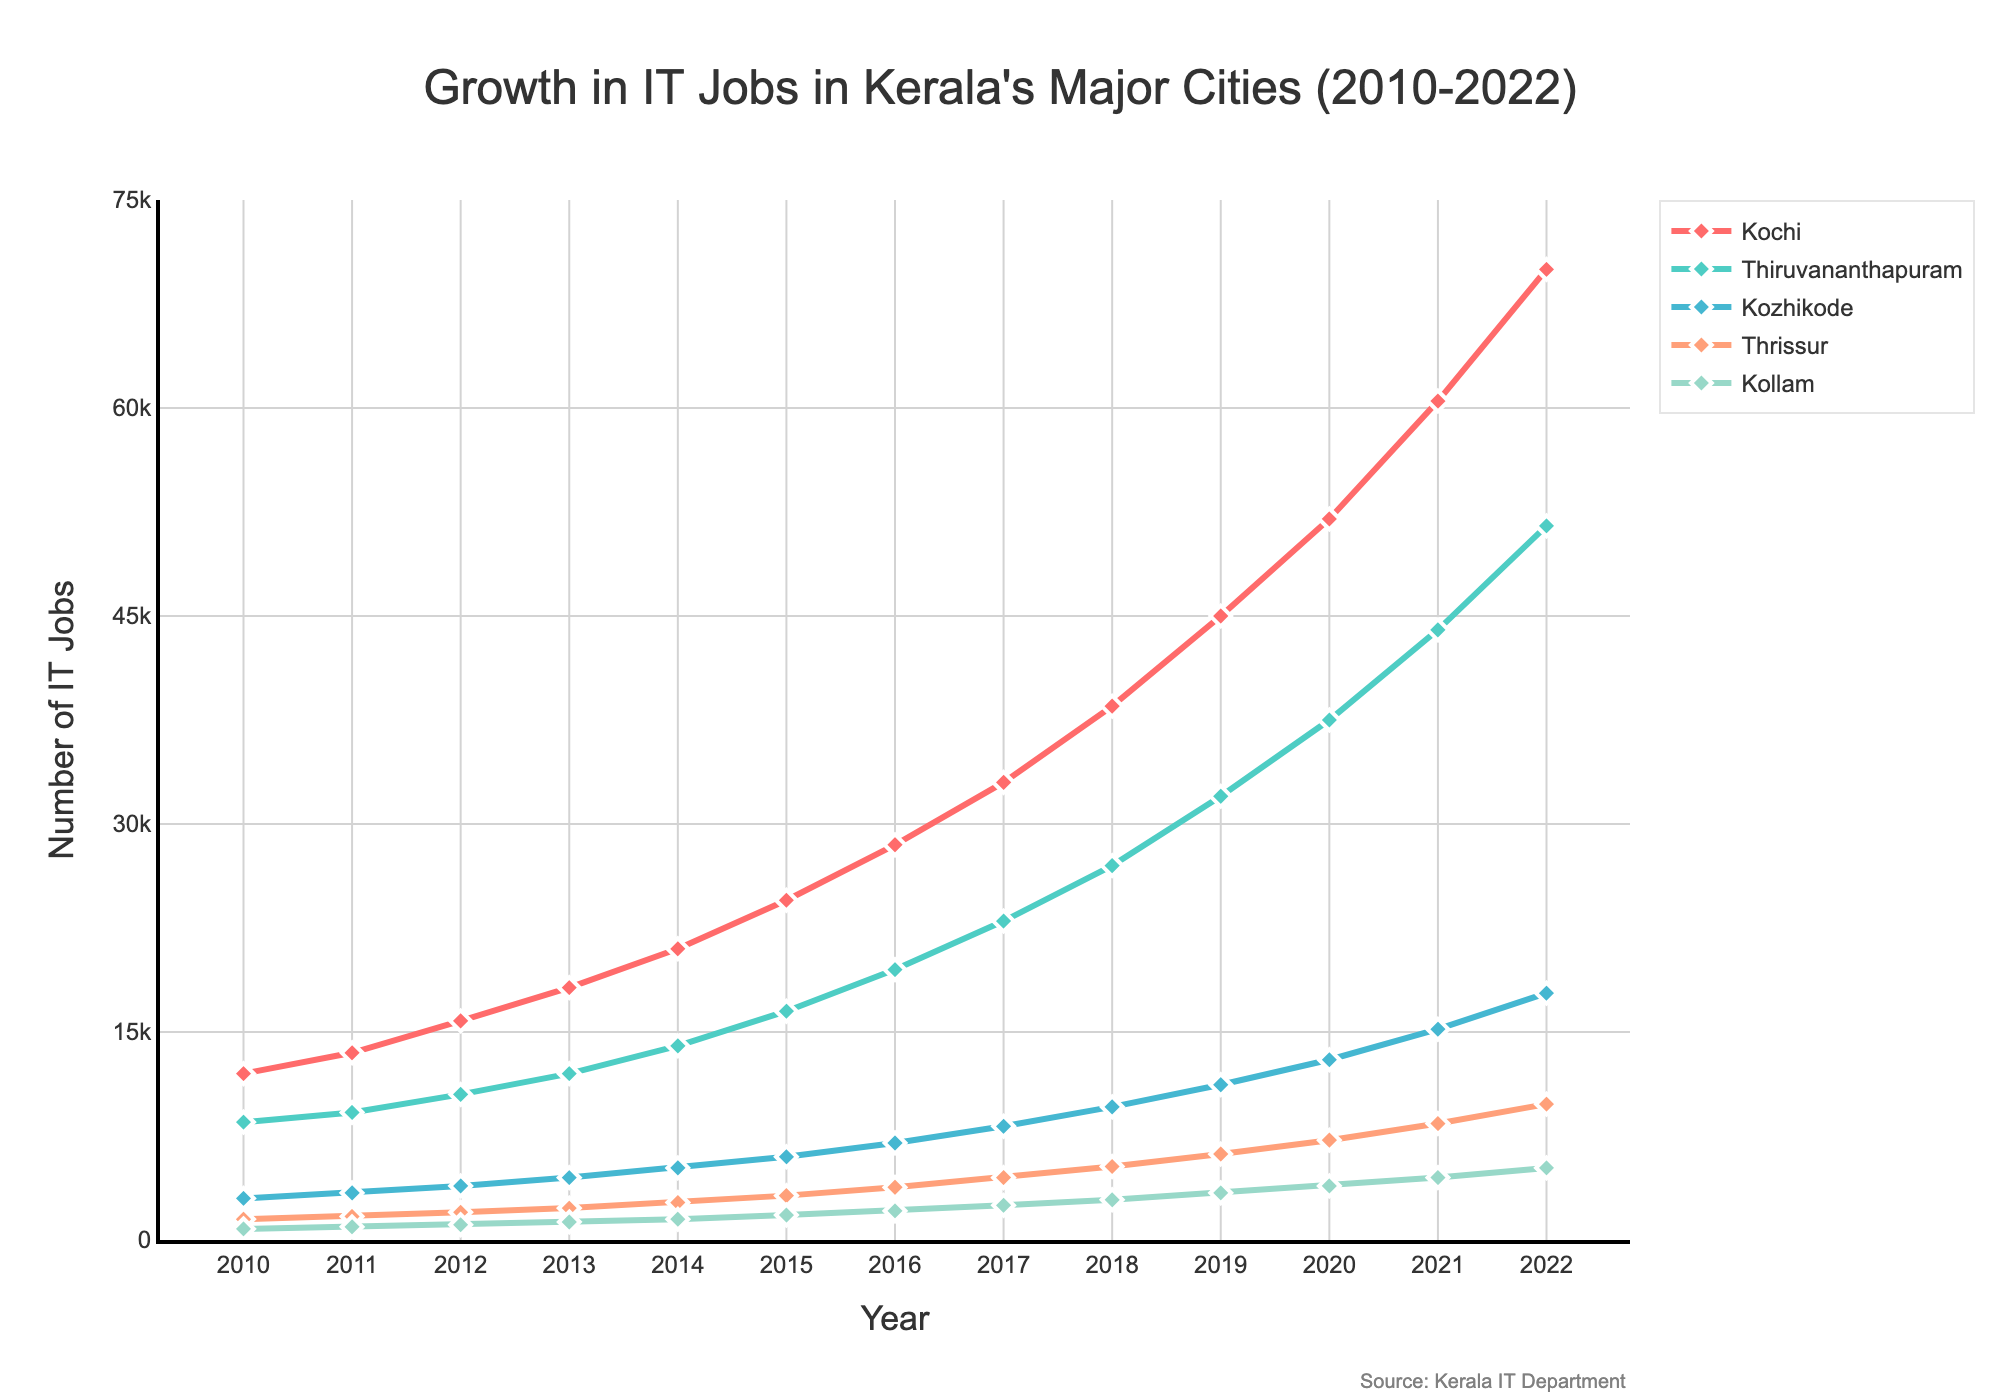What was the total number of IT jobs across all five cities in 2020? To find the total number of IT jobs across all five cities in 2020, sum the number of IT jobs for each city in that year. Kochi had 52000, Thiruvananthapuram had 37500, Kozhikode had 13000, Thrissur had 7200, and Kollam had 3900. Total = 52000 + 37500 + 13000 + 7200 + 3900 = 113600.
Answer: 113600 Which city experienced the highest growth in IT jobs from 2010 to 2022? Calculate the change in IT job numbers from 2010 to 2022 for each city and compare. Kochi: 70000 - 12000 = 58000, Thiruvananthapuram: 51500 - 8500 = 43000, Kozhikode: 17800 - 3000 = 14800, Thrissur: 9800 - 1500 = 8300, Kollam: 5200 - 800 = 4400. Kochi experienced the highest growth with an increase of 58000 jobs.
Answer: Kochi Which two cities had the closest number of IT jobs in 2015? Compare the number of IT jobs in 2015 for all cities. Kochi: 24500, Thiruvananthapuram: 16500, Kozhikode: 6000, Thrissur: 3200, Kollam: 1800. The closest numbers are 3200 (Thrissur) and 1800 (Kollam), with a difference of 1400 jobs.
Answer: Thrissur and Kollam By how much did the number of IT jobs in Kozhikode increase from 2015 to 2020? Subtract the number of IT jobs in 2015 from the number in 2020 for Kozhikode. 2020: 13000, 2015: 6000. Increase = 13000 - 6000 = 7000.
Answer: 7000 What is the average annual growth rate of IT jobs in Thiruvananthapuram from 2010 to 2022? First, find the initial and final number of jobs in Thiruvananthapuram in the given period: initial (2010) = 8500, final (2022) = 51500. Annual growth rate = (final - initial) / number of years = (51500 - 8500) / (2022 - 2010) = 43000 / 12 = 3583.33 jobs per year.
Answer: 3583.33 Which year saw the largest increase in IT jobs for Kochi, and how many jobs were added that year? Calculate the annual increase for each year by subtracting the previous year's number from the current year's number. 2018 to 2019 saw the largest increase: 2019 (45000) - 2018 (38500) = 6500 jobs.
Answer: 2019, 6500 In which city did the number of IT jobs double from 2010 to 2016? Find out whether the number of IT jobs in 2016 is at least double the number of IT jobs in 2010 for each city. Kochi: 28500 (2016) vs. 12000 (2010) — yes, doubled. Thiruvananthapuram: 19500 vs. 8500 — yes. Kozhikode: 7000 vs. 3000 — yes. Thrissur: 3800 vs. 1500 — yes. Kollam: 2100 vs. 800 — yes. All cities doubled their job numbers.
Answer: All cities Between thrissur and Kozhikode, which city saw more consistent growth in IT jobs from 2010 to 2022? Consistent growth implies steady gradual increases without significant fluctuations. By observing the data, Thrissur has relatively steady annual increments: 1500 (2010) to 9800 (2022). Kozhikode also shows consistent growth but Thrissur’s growth is more uniform year after year.
Answer: Thrissur What was the percentage growth in IT jobs for Kollam from 2010 to 2022? Calculate the percentage increase using the formula: ((final number - initial number) / initial number) * 100. Initial (2010) = 800, final (2022) = 5200. Percentage growth = ((5200 - 800) / 800) * 100 = 550%.
Answer: 550% 